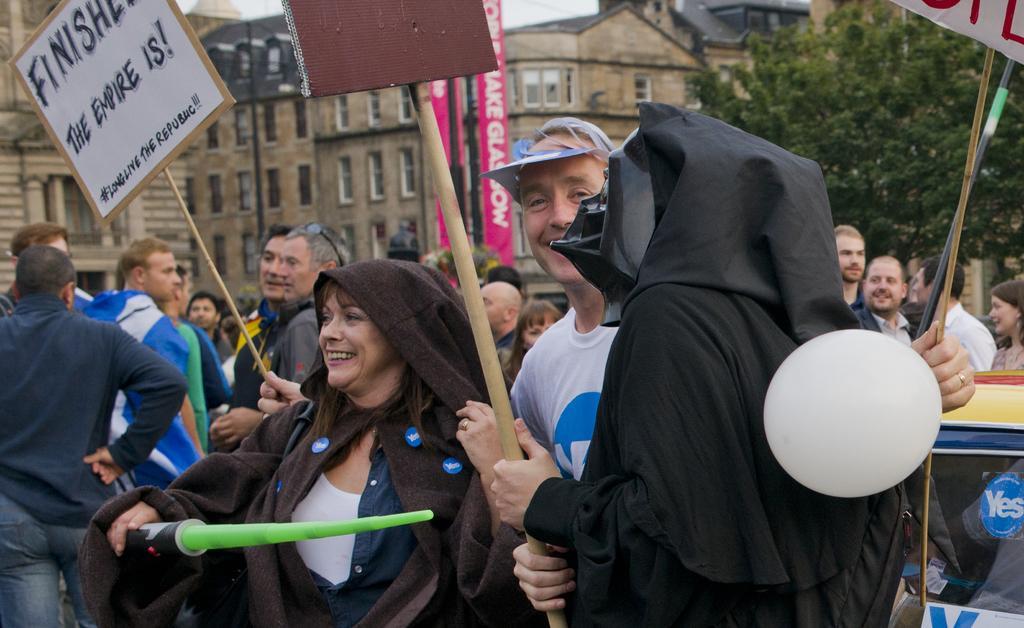Could you give a brief overview of what you see in this image? In the image we can see there are people standing and they are holding banners and posters in their hand. Behind there are trees and buildings. 